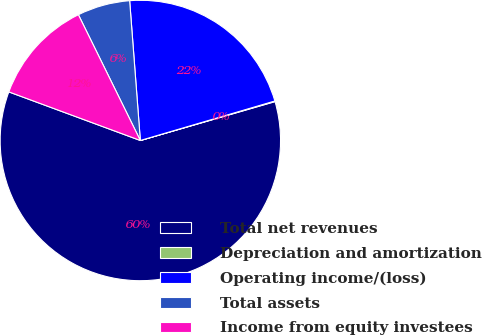Convert chart. <chart><loc_0><loc_0><loc_500><loc_500><pie_chart><fcel>Total net revenues<fcel>Depreciation and amortization<fcel>Operating income/(loss)<fcel>Total assets<fcel>Income from equity investees<nl><fcel>60.11%<fcel>0.07%<fcel>21.67%<fcel>6.07%<fcel>12.08%<nl></chart> 